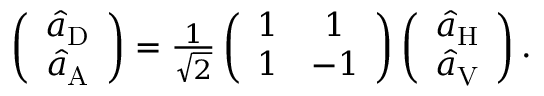<formula> <loc_0><loc_0><loc_500><loc_500>\begin{array} { r } { \left ( \begin{array} { c } { \hat { a } _ { D } } \\ { \hat { a } _ { A } } \end{array} \right ) = \frac { 1 } { \sqrt { 2 } } \left ( \begin{array} { c c } { 1 } & { 1 } \\ { 1 } & { - 1 } \end{array} \right ) \left ( \begin{array} { c } { \hat { a } _ { H } } \\ { \hat { a } _ { V } } \end{array} \right ) . } \end{array}</formula> 